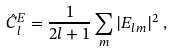Convert formula to latex. <formula><loc_0><loc_0><loc_500><loc_500>\hat { C } _ { l } ^ { E } = \frac { 1 } { 2 l + 1 } \sum _ { m } | E _ { l m } | ^ { 2 } \, ,</formula> 